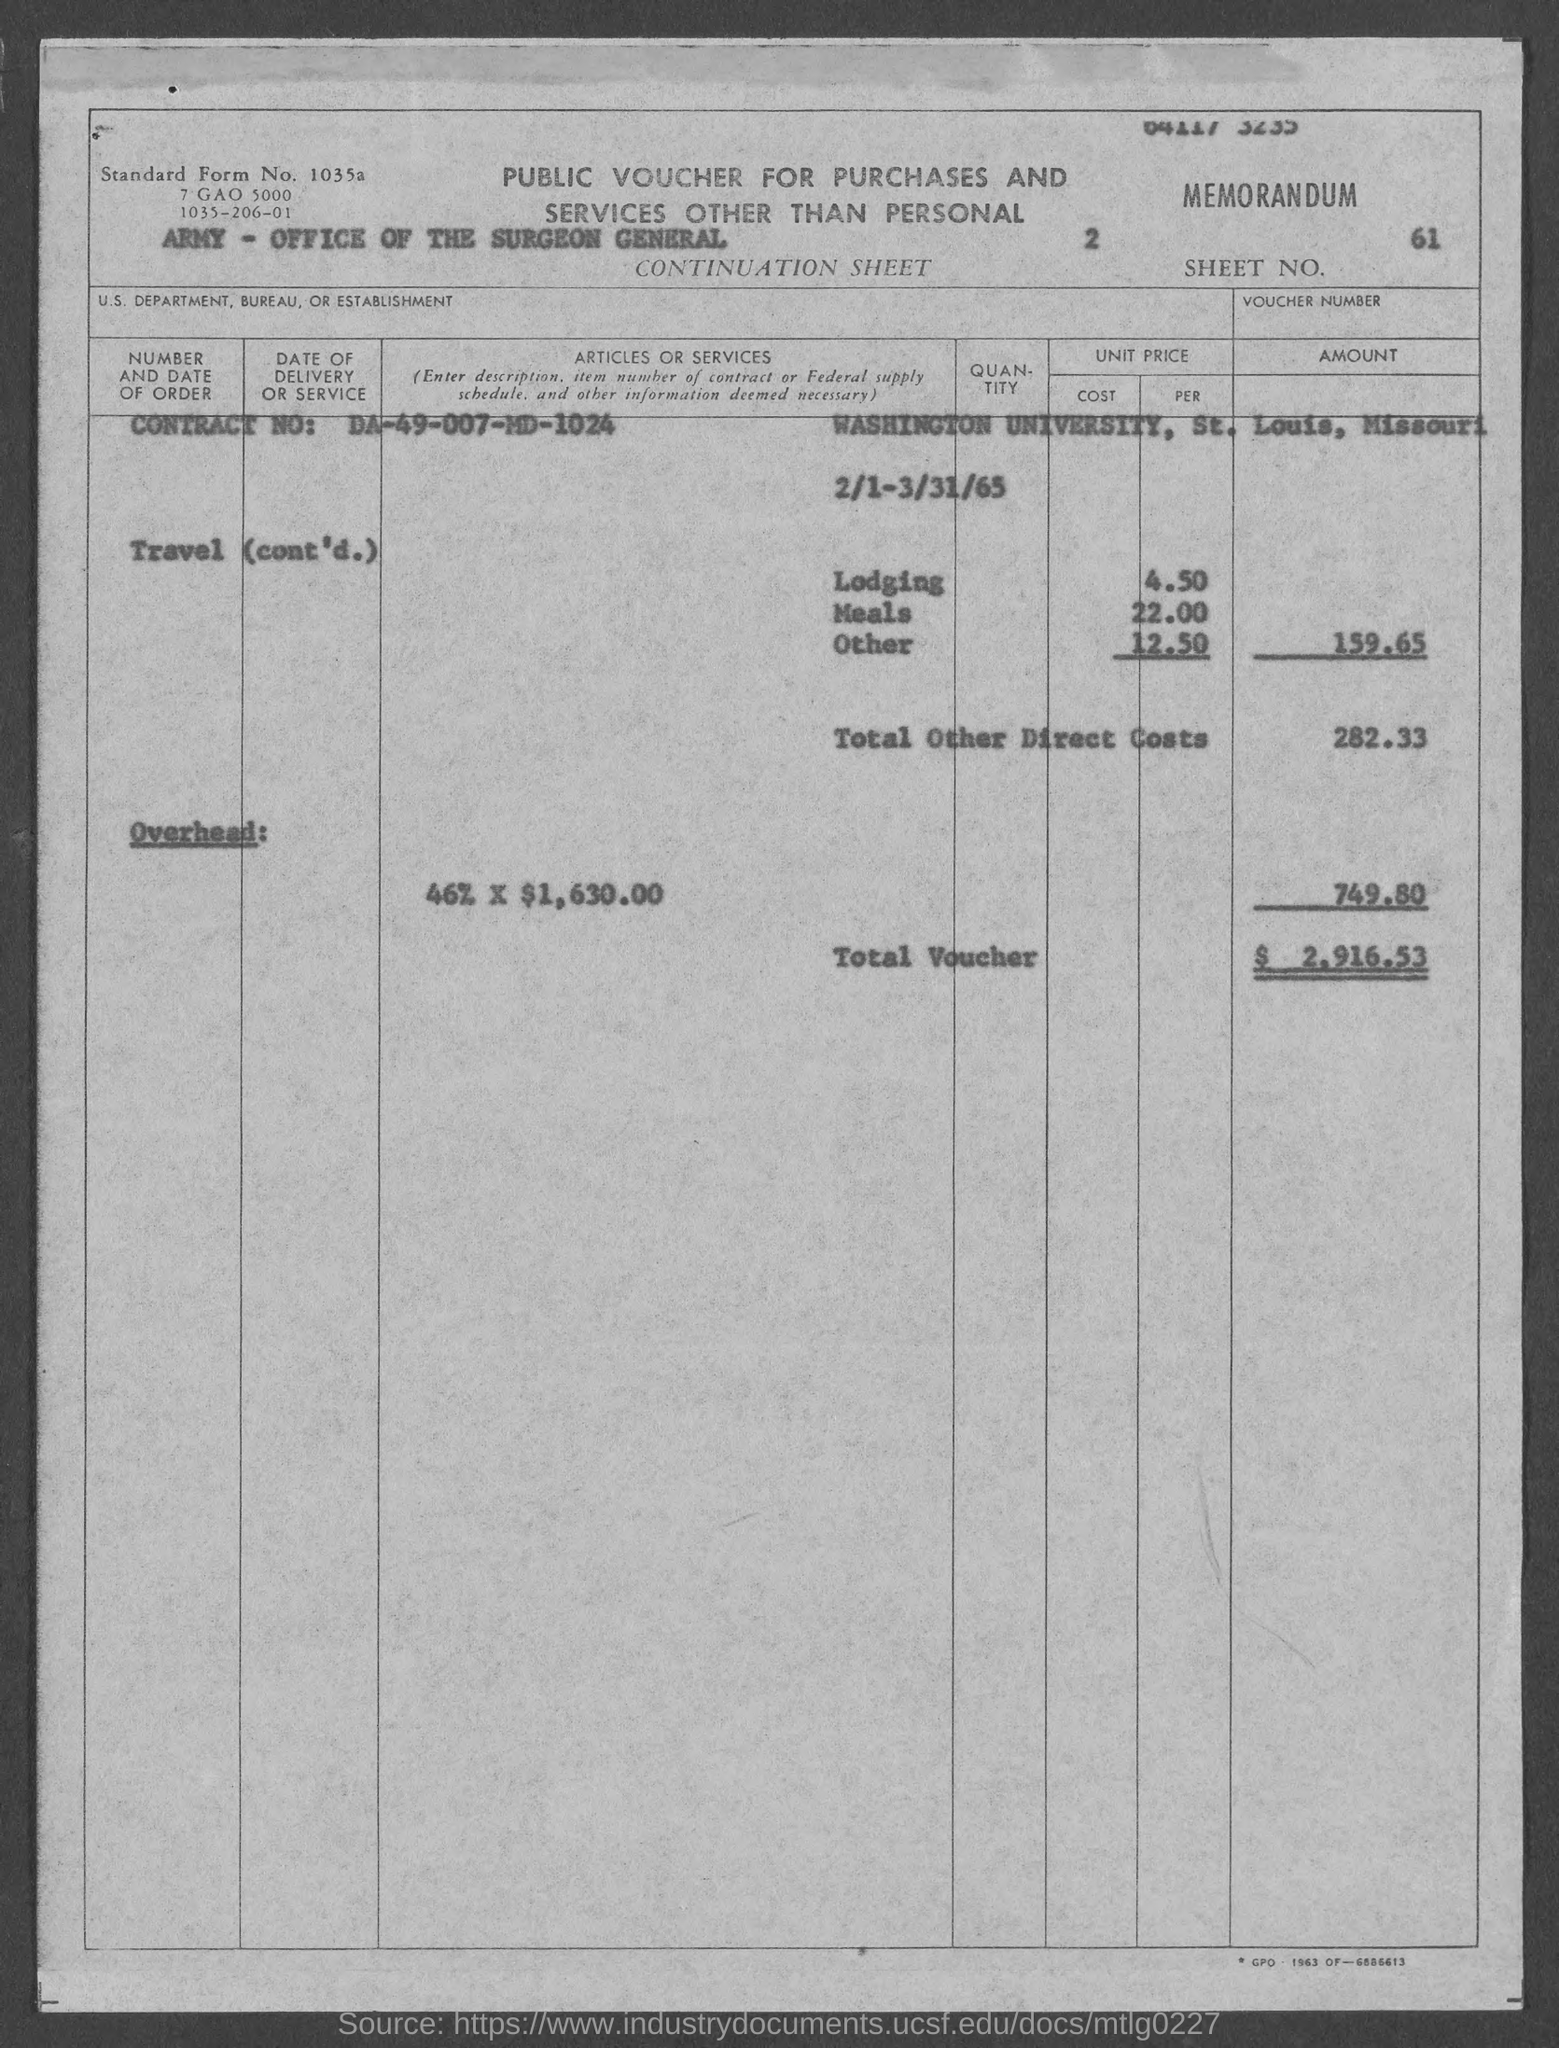List a handful of essential elements in this visual. The Sheet No. is 61. The total voucher amount is $2,916.53. The Contract No. is DA-49-007-MD-1024. The total other direct costs are 282.33... 